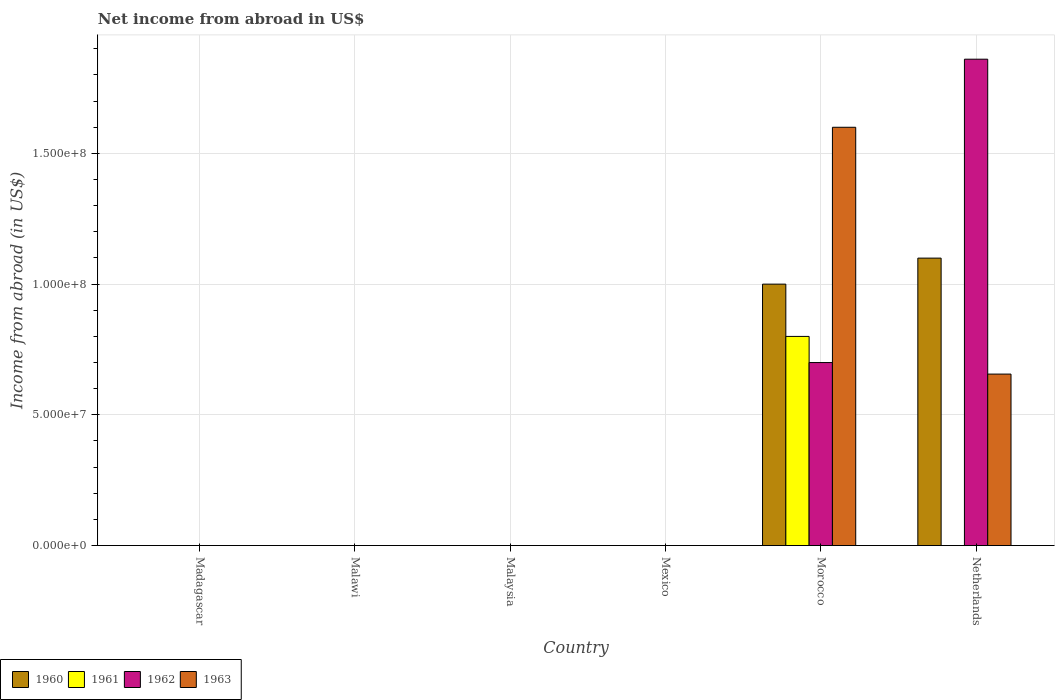Are the number of bars per tick equal to the number of legend labels?
Your answer should be very brief. No. Are the number of bars on each tick of the X-axis equal?
Give a very brief answer. No. How many bars are there on the 3rd tick from the left?
Offer a terse response. 0. How many bars are there on the 4th tick from the right?
Your response must be concise. 0. What is the label of the 6th group of bars from the left?
Make the answer very short. Netherlands. In how many cases, is the number of bars for a given country not equal to the number of legend labels?
Offer a very short reply. 5. Across all countries, what is the maximum net income from abroad in 1962?
Your answer should be compact. 1.86e+08. In which country was the net income from abroad in 1961 maximum?
Offer a terse response. Morocco. What is the total net income from abroad in 1962 in the graph?
Provide a short and direct response. 2.56e+08. What is the difference between the net income from abroad in 1960 in Morocco and that in Netherlands?
Your response must be concise. -9.95e+06. What is the average net income from abroad in 1963 per country?
Ensure brevity in your answer.  3.76e+07. What is the difference between the net income from abroad of/in 1962 and net income from abroad of/in 1960 in Morocco?
Your answer should be very brief. -3.00e+07. In how many countries, is the net income from abroad in 1963 greater than 110000000 US$?
Offer a terse response. 1. What is the difference between the highest and the lowest net income from abroad in 1963?
Keep it short and to the point. 1.60e+08. In how many countries, is the net income from abroad in 1962 greater than the average net income from abroad in 1962 taken over all countries?
Give a very brief answer. 2. Is it the case that in every country, the sum of the net income from abroad in 1963 and net income from abroad in 1961 is greater than the sum of net income from abroad in 1960 and net income from abroad in 1962?
Make the answer very short. No. Is it the case that in every country, the sum of the net income from abroad in 1963 and net income from abroad in 1960 is greater than the net income from abroad in 1961?
Your answer should be very brief. No. Does the graph contain any zero values?
Your answer should be very brief. Yes. Does the graph contain grids?
Offer a very short reply. Yes. How many legend labels are there?
Your answer should be very brief. 4. What is the title of the graph?
Keep it short and to the point. Net income from abroad in US$. Does "2008" appear as one of the legend labels in the graph?
Provide a succinct answer. No. What is the label or title of the X-axis?
Give a very brief answer. Country. What is the label or title of the Y-axis?
Provide a succinct answer. Income from abroad (in US$). What is the Income from abroad (in US$) in 1960 in Madagascar?
Offer a very short reply. 0. What is the Income from abroad (in US$) in 1962 in Madagascar?
Your response must be concise. 0. What is the Income from abroad (in US$) of 1960 in Malawi?
Make the answer very short. 0. What is the Income from abroad (in US$) in 1962 in Malawi?
Provide a succinct answer. 0. What is the Income from abroad (in US$) of 1963 in Malawi?
Your answer should be very brief. 0. What is the Income from abroad (in US$) of 1961 in Malaysia?
Ensure brevity in your answer.  0. What is the Income from abroad (in US$) of 1960 in Mexico?
Ensure brevity in your answer.  0. What is the Income from abroad (in US$) of 1960 in Morocco?
Your answer should be very brief. 1.00e+08. What is the Income from abroad (in US$) of 1961 in Morocco?
Your response must be concise. 8.00e+07. What is the Income from abroad (in US$) of 1962 in Morocco?
Offer a very short reply. 7.00e+07. What is the Income from abroad (in US$) of 1963 in Morocco?
Your answer should be compact. 1.60e+08. What is the Income from abroad (in US$) in 1960 in Netherlands?
Make the answer very short. 1.10e+08. What is the Income from abroad (in US$) of 1962 in Netherlands?
Your answer should be compact. 1.86e+08. What is the Income from abroad (in US$) in 1963 in Netherlands?
Offer a very short reply. 6.56e+07. Across all countries, what is the maximum Income from abroad (in US$) of 1960?
Your response must be concise. 1.10e+08. Across all countries, what is the maximum Income from abroad (in US$) in 1961?
Keep it short and to the point. 8.00e+07. Across all countries, what is the maximum Income from abroad (in US$) of 1962?
Your answer should be very brief. 1.86e+08. Across all countries, what is the maximum Income from abroad (in US$) in 1963?
Offer a very short reply. 1.60e+08. Across all countries, what is the minimum Income from abroad (in US$) of 1960?
Keep it short and to the point. 0. Across all countries, what is the minimum Income from abroad (in US$) of 1962?
Ensure brevity in your answer.  0. What is the total Income from abroad (in US$) in 1960 in the graph?
Offer a very short reply. 2.10e+08. What is the total Income from abroad (in US$) in 1961 in the graph?
Provide a short and direct response. 8.00e+07. What is the total Income from abroad (in US$) in 1962 in the graph?
Give a very brief answer. 2.56e+08. What is the total Income from abroad (in US$) of 1963 in the graph?
Your response must be concise. 2.26e+08. What is the difference between the Income from abroad (in US$) in 1960 in Morocco and that in Netherlands?
Provide a short and direct response. -9.95e+06. What is the difference between the Income from abroad (in US$) of 1962 in Morocco and that in Netherlands?
Your answer should be very brief. -1.16e+08. What is the difference between the Income from abroad (in US$) of 1963 in Morocco and that in Netherlands?
Ensure brevity in your answer.  9.44e+07. What is the difference between the Income from abroad (in US$) in 1960 in Morocco and the Income from abroad (in US$) in 1962 in Netherlands?
Your response must be concise. -8.60e+07. What is the difference between the Income from abroad (in US$) of 1960 in Morocco and the Income from abroad (in US$) of 1963 in Netherlands?
Your answer should be very brief. 3.44e+07. What is the difference between the Income from abroad (in US$) of 1961 in Morocco and the Income from abroad (in US$) of 1962 in Netherlands?
Give a very brief answer. -1.06e+08. What is the difference between the Income from abroad (in US$) in 1961 in Morocco and the Income from abroad (in US$) in 1963 in Netherlands?
Keep it short and to the point. 1.44e+07. What is the difference between the Income from abroad (in US$) in 1962 in Morocco and the Income from abroad (in US$) in 1963 in Netherlands?
Offer a terse response. 4.41e+06. What is the average Income from abroad (in US$) of 1960 per country?
Your answer should be very brief. 3.50e+07. What is the average Income from abroad (in US$) of 1961 per country?
Offer a terse response. 1.33e+07. What is the average Income from abroad (in US$) of 1962 per country?
Make the answer very short. 4.27e+07. What is the average Income from abroad (in US$) in 1963 per country?
Provide a succinct answer. 3.76e+07. What is the difference between the Income from abroad (in US$) in 1960 and Income from abroad (in US$) in 1961 in Morocco?
Ensure brevity in your answer.  2.00e+07. What is the difference between the Income from abroad (in US$) in 1960 and Income from abroad (in US$) in 1962 in Morocco?
Keep it short and to the point. 3.00e+07. What is the difference between the Income from abroad (in US$) in 1960 and Income from abroad (in US$) in 1963 in Morocco?
Ensure brevity in your answer.  -6.00e+07. What is the difference between the Income from abroad (in US$) of 1961 and Income from abroad (in US$) of 1962 in Morocco?
Make the answer very short. 1.00e+07. What is the difference between the Income from abroad (in US$) in 1961 and Income from abroad (in US$) in 1963 in Morocco?
Ensure brevity in your answer.  -8.00e+07. What is the difference between the Income from abroad (in US$) in 1962 and Income from abroad (in US$) in 1963 in Morocco?
Offer a terse response. -9.00e+07. What is the difference between the Income from abroad (in US$) in 1960 and Income from abroad (in US$) in 1962 in Netherlands?
Provide a succinct answer. -7.61e+07. What is the difference between the Income from abroad (in US$) in 1960 and Income from abroad (in US$) in 1963 in Netherlands?
Make the answer very short. 4.44e+07. What is the difference between the Income from abroad (in US$) in 1962 and Income from abroad (in US$) in 1963 in Netherlands?
Keep it short and to the point. 1.20e+08. What is the ratio of the Income from abroad (in US$) of 1960 in Morocco to that in Netherlands?
Your response must be concise. 0.91. What is the ratio of the Income from abroad (in US$) in 1962 in Morocco to that in Netherlands?
Make the answer very short. 0.38. What is the ratio of the Income from abroad (in US$) of 1963 in Morocco to that in Netherlands?
Keep it short and to the point. 2.44. What is the difference between the highest and the lowest Income from abroad (in US$) in 1960?
Provide a short and direct response. 1.10e+08. What is the difference between the highest and the lowest Income from abroad (in US$) in 1961?
Keep it short and to the point. 8.00e+07. What is the difference between the highest and the lowest Income from abroad (in US$) in 1962?
Keep it short and to the point. 1.86e+08. What is the difference between the highest and the lowest Income from abroad (in US$) of 1963?
Ensure brevity in your answer.  1.60e+08. 